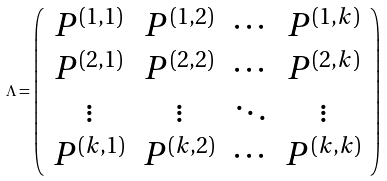<formula> <loc_0><loc_0><loc_500><loc_500>\Lambda = \left ( \begin{array} { c c c c } P ^ { ( 1 , 1 ) } & P ^ { ( 1 , 2 ) } & \cdots & P ^ { ( 1 , k ) } \\ P ^ { ( 2 , 1 ) } & P ^ { ( 2 , 2 ) } & \cdots & P ^ { ( 2 , k ) } \\ \vdots & \vdots & \ddots & \vdots \\ P ^ { ( k , 1 ) } & P ^ { ( k , 2 ) } & \cdots & P ^ { ( k , k ) } \end{array} \right )</formula> 